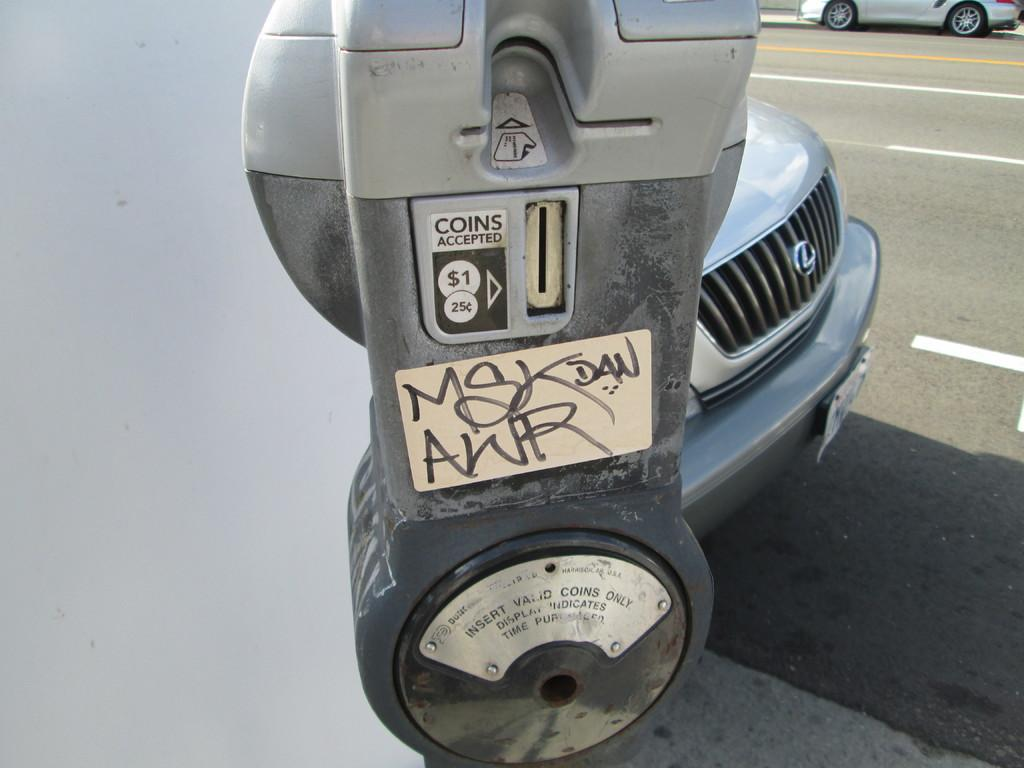<image>
Write a terse but informative summary of the picture. A silver and dark gray colored parking meter that accepts $1 and 25 cent coins. 